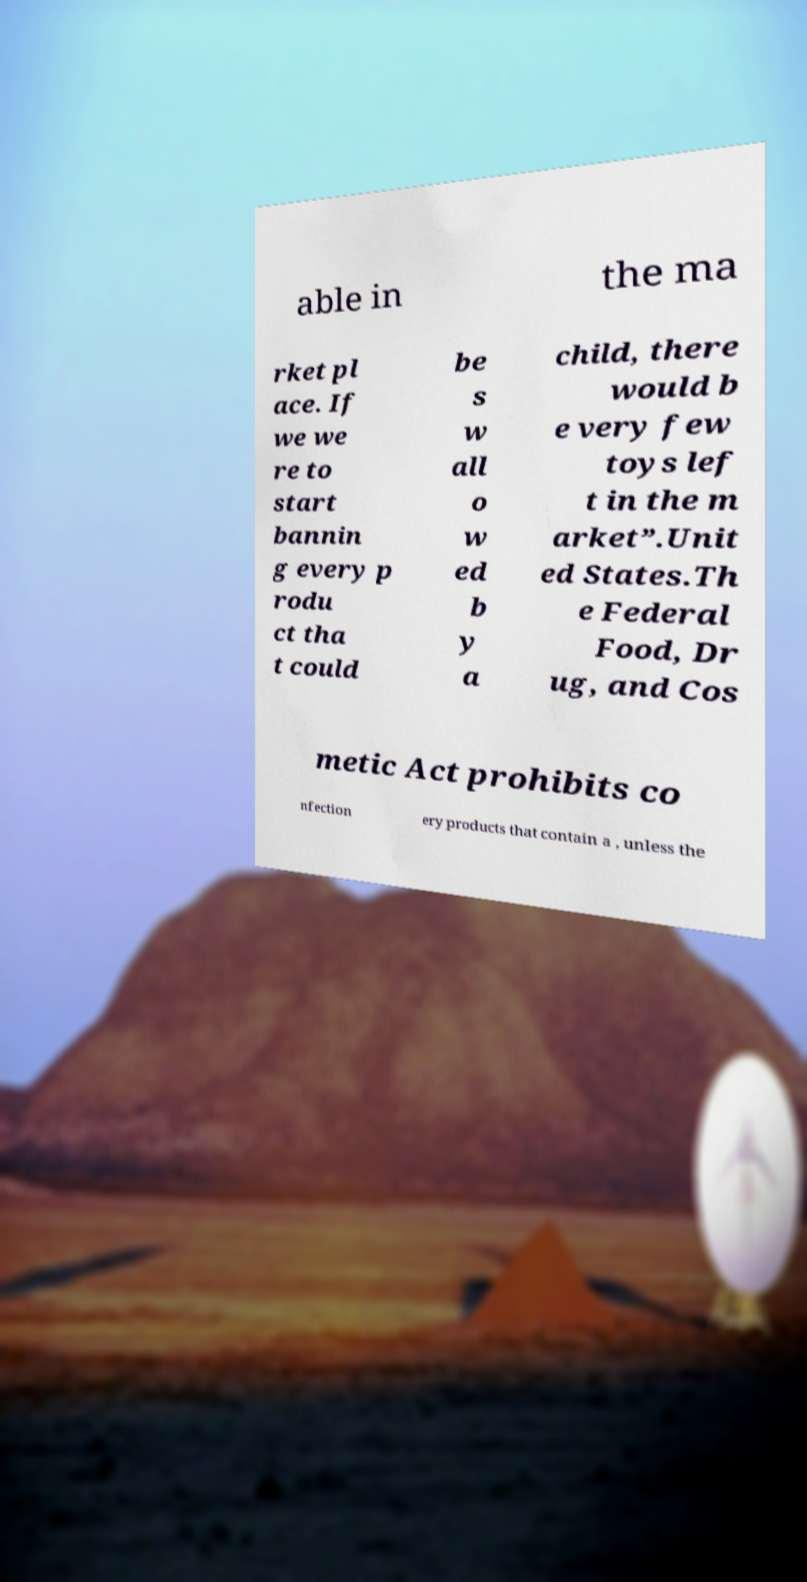For documentation purposes, I need the text within this image transcribed. Could you provide that? able in the ma rket pl ace. If we we re to start bannin g every p rodu ct tha t could be s w all o w ed b y a child, there would b e very few toys lef t in the m arket”.Unit ed States.Th e Federal Food, Dr ug, and Cos metic Act prohibits co nfection ery products that contain a , unless the 